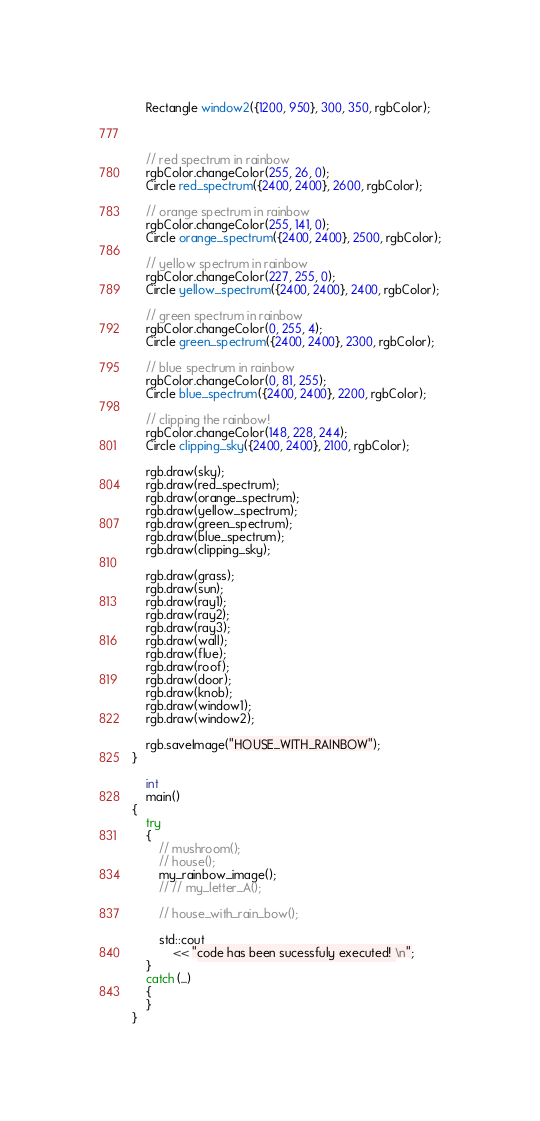Convert code to text. <code><loc_0><loc_0><loc_500><loc_500><_C++_>    Rectangle window2({1200, 950}, 300, 350, rgbColor);

    

    // red spectrum in rainbow
    rgbColor.changeColor(255, 26, 0);
    Circle red_spectrum({2400, 2400}, 2600, rgbColor);

    // orange spectrum in rainbow
    rgbColor.changeColor(255, 141, 0);
    Circle orange_spectrum({2400, 2400}, 2500, rgbColor);

    // yellow spectrum in rainbow
    rgbColor.changeColor(227, 255, 0);
    Circle yellow_spectrum({2400, 2400}, 2400, rgbColor);

    // green spectrum in rainbow
    rgbColor.changeColor(0, 255, 4);
    Circle green_spectrum({2400, 2400}, 2300, rgbColor);

    // blue spectrum in rainbow
    rgbColor.changeColor(0, 81, 255);
    Circle blue_spectrum({2400, 2400}, 2200, rgbColor);

    // clipping the rainbow!
    rgbColor.changeColor(148, 228, 244);
    Circle clipping_sky({2400, 2400}, 2100, rgbColor);

    rgb.draw(sky);
    rgb.draw(red_spectrum);
    rgb.draw(orange_spectrum);
    rgb.draw(yellow_spectrum);
    rgb.draw(green_spectrum);
    rgb.draw(blue_spectrum);
    rgb.draw(clipping_sky);

    rgb.draw(grass);
    rgb.draw(sun);
    rgb.draw(ray1);
    rgb.draw(ray2);
    rgb.draw(ray3);
    rgb.draw(wall);
    rgb.draw(flue);
    rgb.draw(roof);
    rgb.draw(door);
    rgb.draw(knob);
    rgb.draw(window1);
    rgb.draw(window2);

    rgb.saveImage("HOUSE_WITH_RAINBOW");
}

    int
    main()
{
    try
    {
        // mushroom();
        // house();
        my_rainbow_image();
        // // my_letter_A();

        // house_with_rain_bow();

        std::cout
            << "code has been sucessfuly executed! \n";
    }
    catch (...)
    {
    }
}
</code> 